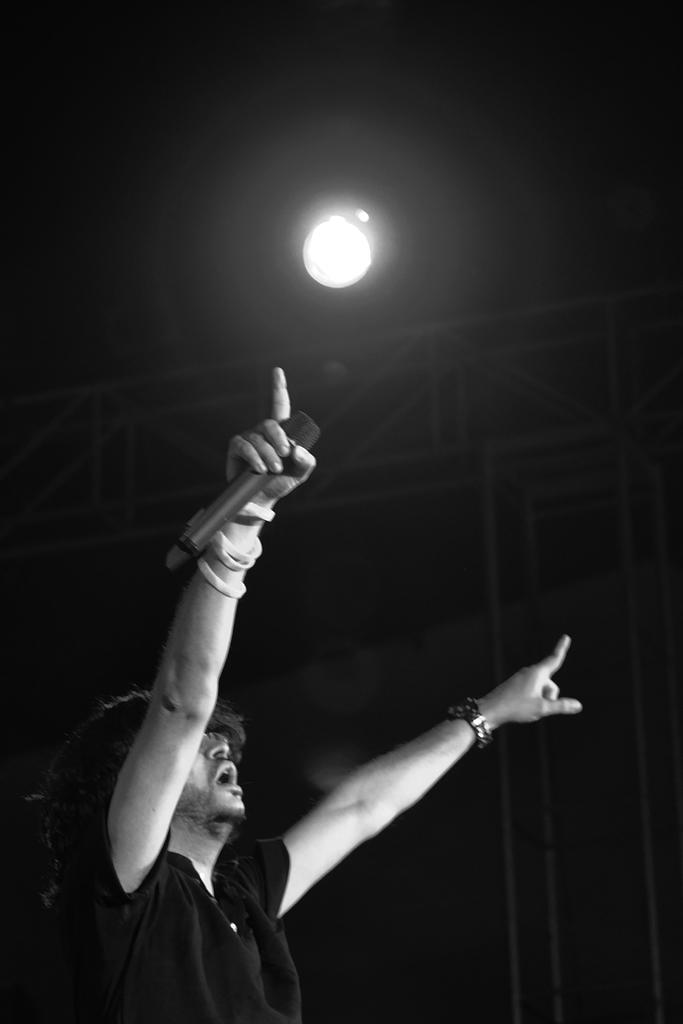What is the color scheme of the image? The image is black and white. Who is present in the image? There is a man in the image. What is the man holding in his hand? The man is holding a microphone in his hand. How is the background of the image illuminated? The background of the image has light. How many ladybugs can be seen crawling on the microphone in the image? There are no ladybugs present in the image; it only features a man holding a microphone. What type of lettuce is visible in the background of the image? There is no lettuce present in the image; the background has light, but no specific vegetable is mentioned. 